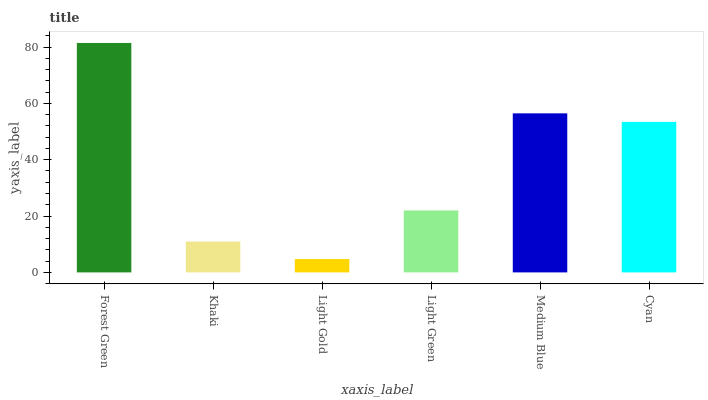Is Light Gold the minimum?
Answer yes or no. Yes. Is Forest Green the maximum?
Answer yes or no. Yes. Is Khaki the minimum?
Answer yes or no. No. Is Khaki the maximum?
Answer yes or no. No. Is Forest Green greater than Khaki?
Answer yes or no. Yes. Is Khaki less than Forest Green?
Answer yes or no. Yes. Is Khaki greater than Forest Green?
Answer yes or no. No. Is Forest Green less than Khaki?
Answer yes or no. No. Is Cyan the high median?
Answer yes or no. Yes. Is Light Green the low median?
Answer yes or no. Yes. Is Medium Blue the high median?
Answer yes or no. No. Is Light Gold the low median?
Answer yes or no. No. 